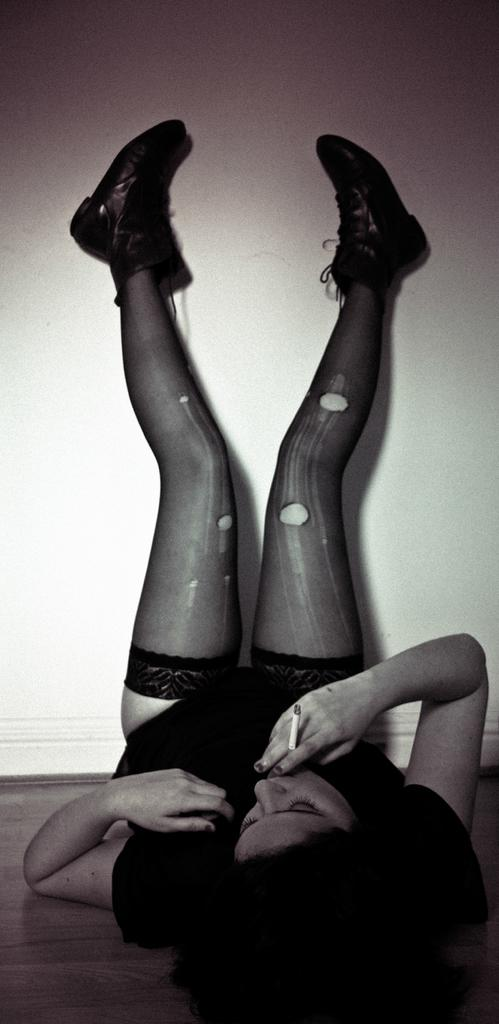What is the color scheme of the image? The image is black and white. Who is present in the image? There is a woman in the image. What is the woman holding in her fingers? The woman is holding a cigar in her fingers. What position is the woman in? The woman is lying on the floor with raised legs. How many chairs are visible in the image? There are no chairs visible in the image. What type of jeans is the woman wearing in the image? The image is black and white, and there is no information about the woman's clothing, so we cannot determine if she is wearing jeans or any other type of clothing. 